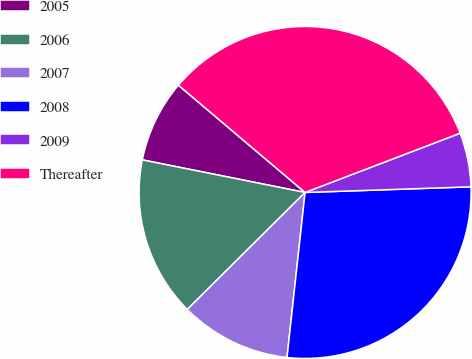Convert chart. <chart><loc_0><loc_0><loc_500><loc_500><pie_chart><fcel>2005<fcel>2006<fcel>2007<fcel>2008<fcel>2009<fcel>Thereafter<nl><fcel>8.04%<fcel>15.59%<fcel>10.82%<fcel>27.28%<fcel>5.27%<fcel>33.01%<nl></chart> 